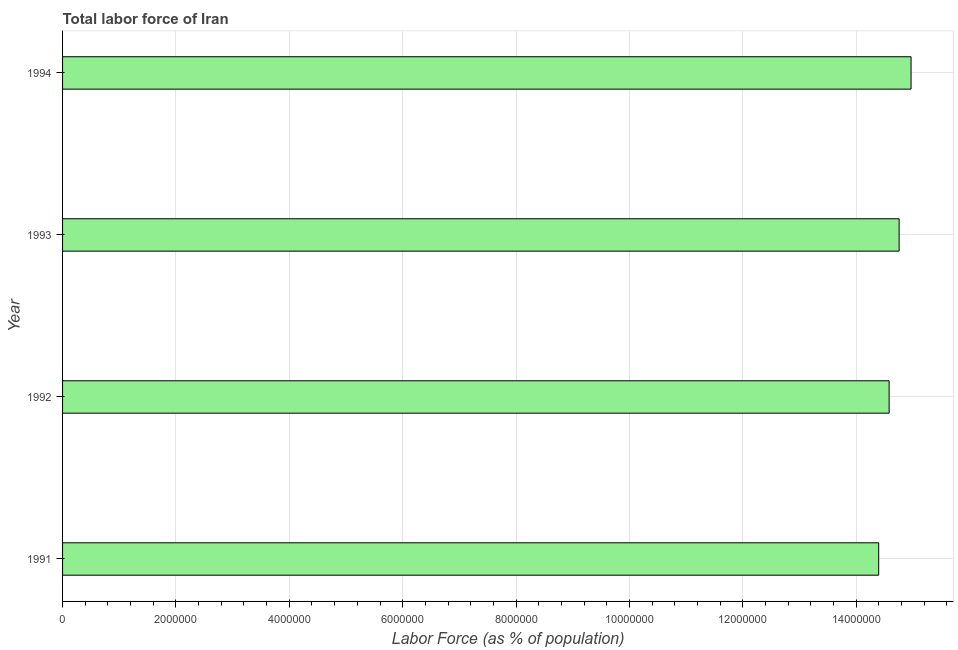Does the graph contain grids?
Offer a very short reply. Yes. What is the title of the graph?
Offer a very short reply. Total labor force of Iran. What is the label or title of the X-axis?
Offer a terse response. Labor Force (as % of population). What is the label or title of the Y-axis?
Make the answer very short. Year. What is the total labor force in 1993?
Offer a terse response. 1.48e+07. Across all years, what is the maximum total labor force?
Give a very brief answer. 1.50e+07. Across all years, what is the minimum total labor force?
Your answer should be very brief. 1.44e+07. In which year was the total labor force maximum?
Provide a short and direct response. 1994. In which year was the total labor force minimum?
Your answer should be very brief. 1991. What is the sum of the total labor force?
Give a very brief answer. 5.87e+07. What is the difference between the total labor force in 1991 and 1992?
Offer a terse response. -1.84e+05. What is the average total labor force per year?
Ensure brevity in your answer.  1.47e+07. What is the median total labor force?
Keep it short and to the point. 1.47e+07. In how many years, is the total labor force greater than 13200000 %?
Keep it short and to the point. 4. Do a majority of the years between 1991 and 1992 (inclusive) have total labor force greater than 3600000 %?
Offer a very short reply. Yes. What is the difference between the highest and the second highest total labor force?
Provide a short and direct response. 2.11e+05. What is the difference between the highest and the lowest total labor force?
Ensure brevity in your answer.  5.71e+05. In how many years, is the total labor force greater than the average total labor force taken over all years?
Make the answer very short. 2. How many bars are there?
Your response must be concise. 4. What is the difference between two consecutive major ticks on the X-axis?
Offer a very short reply. 2.00e+06. Are the values on the major ticks of X-axis written in scientific E-notation?
Offer a terse response. No. What is the Labor Force (as % of population) in 1991?
Provide a succinct answer. 1.44e+07. What is the Labor Force (as % of population) of 1992?
Offer a very short reply. 1.46e+07. What is the Labor Force (as % of population) in 1993?
Ensure brevity in your answer.  1.48e+07. What is the Labor Force (as % of population) of 1994?
Offer a very short reply. 1.50e+07. What is the difference between the Labor Force (as % of population) in 1991 and 1992?
Provide a succinct answer. -1.84e+05. What is the difference between the Labor Force (as % of population) in 1991 and 1993?
Keep it short and to the point. -3.60e+05. What is the difference between the Labor Force (as % of population) in 1991 and 1994?
Provide a succinct answer. -5.71e+05. What is the difference between the Labor Force (as % of population) in 1992 and 1993?
Give a very brief answer. -1.76e+05. What is the difference between the Labor Force (as % of population) in 1992 and 1994?
Offer a very short reply. -3.87e+05. What is the difference between the Labor Force (as % of population) in 1993 and 1994?
Offer a terse response. -2.11e+05. What is the ratio of the Labor Force (as % of population) in 1991 to that in 1992?
Ensure brevity in your answer.  0.99. What is the ratio of the Labor Force (as % of population) in 1991 to that in 1994?
Offer a very short reply. 0.96. What is the ratio of the Labor Force (as % of population) in 1992 to that in 1993?
Offer a very short reply. 0.99. 